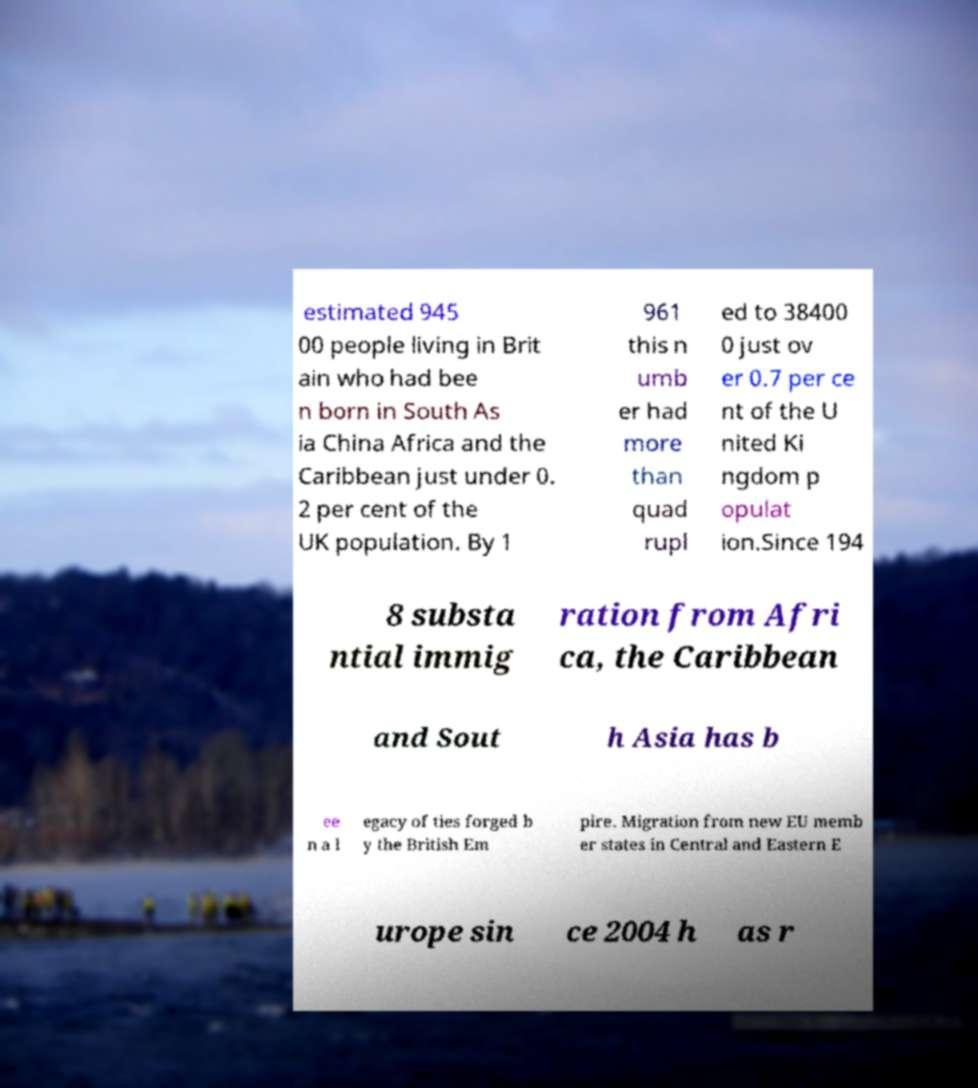Can you read and provide the text displayed in the image?This photo seems to have some interesting text. Can you extract and type it out for me? estimated 945 00 people living in Brit ain who had bee n born in South As ia China Africa and the Caribbean just under 0. 2 per cent of the UK population. By 1 961 this n umb er had more than quad rupl ed to 38400 0 just ov er 0.7 per ce nt of the U nited Ki ngdom p opulat ion.Since 194 8 substa ntial immig ration from Afri ca, the Caribbean and Sout h Asia has b ee n a l egacy of ties forged b y the British Em pire. Migration from new EU memb er states in Central and Eastern E urope sin ce 2004 h as r 